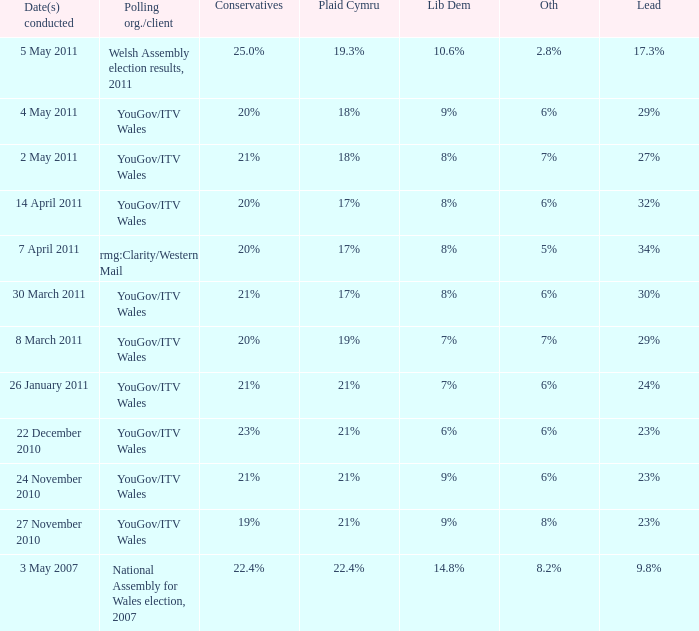I want the plaid cymru for 4 may 2011 18%. 